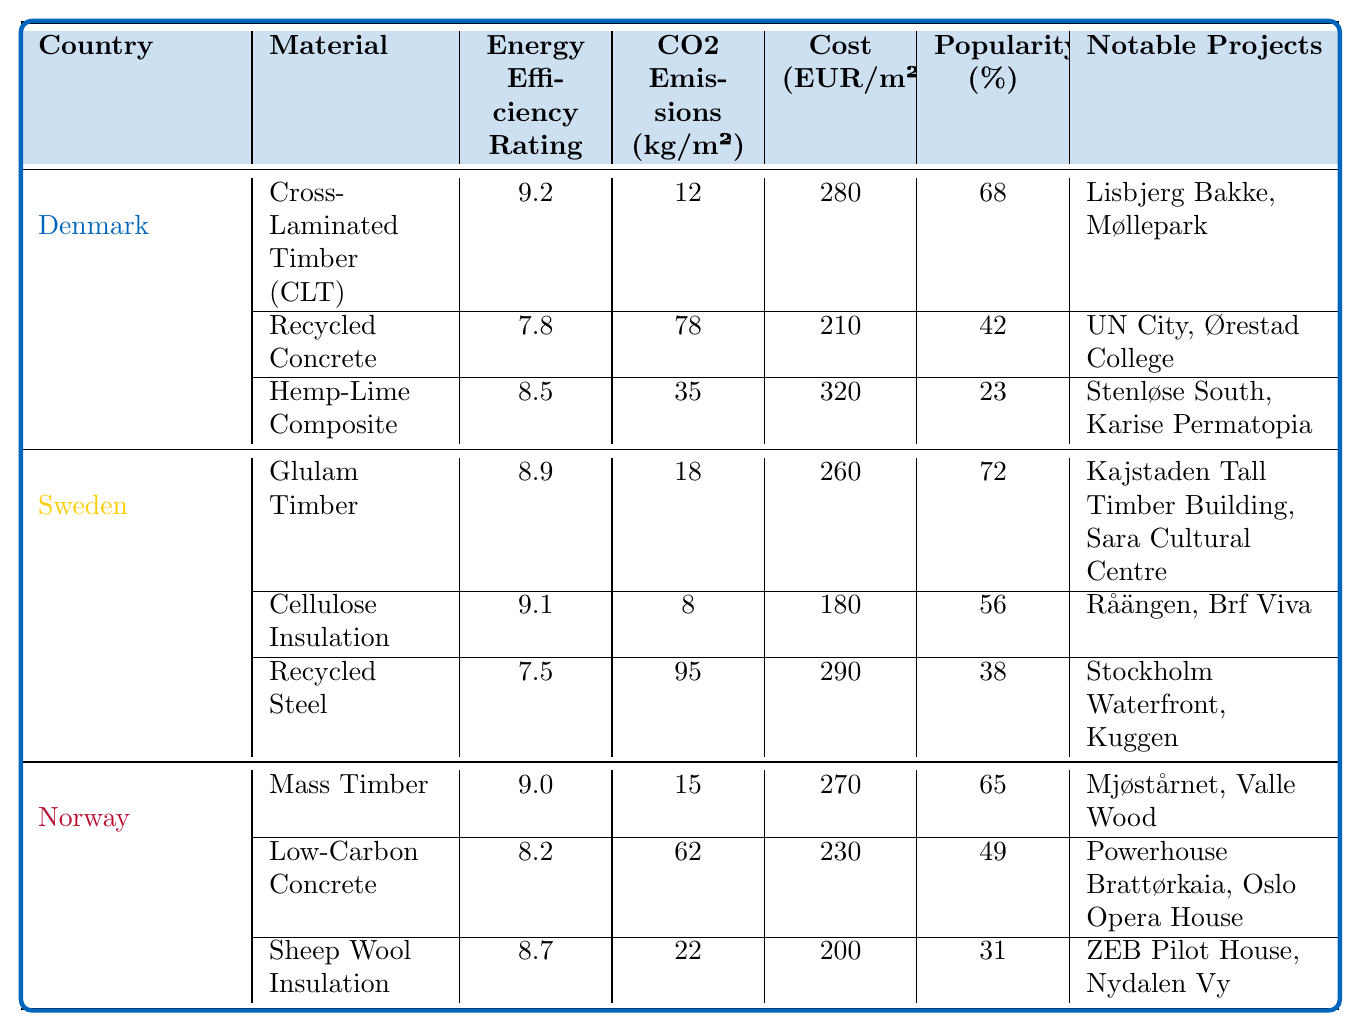What is the energy efficiency rating of Cross-Laminated Timber (CLT) in Denmark? The energy efficiency rating for Cross-Laminated Timber (CLT) is listed in the table under Denmark, where it shows a rating of 9.2.
Answer: 9.2 Which building material in Sweden has the lowest CO2 emissions per square meter? In the table for Sweden, Cellulose Insulation has the lowest CO2 emissions at 8 kg/m² compared to Glulam Timber (18 kg/m²) and Recycled Steel (95 kg/m²).
Answer: Cellulose Insulation What is the cost per square meter of Hemp-Lime Composite in Denmark? The table indicates that the cost of Hemp-Lime Composite in Denmark is 320 EUR/m².
Answer: 320 What are the notable projects that utilize Low-Carbon Concrete in Norway? Referring to the table, the notable projects using Low-Carbon Concrete in Norway are Powerhouse Brattørkaia and Oslo Opera House.
Answer: Powerhouse Brattørkaia, Oslo Opera House Which country has the building material with the highest energy efficiency rating? Denmark has Cross-Laminated Timber (CLT) with the highest energy efficiency rating of 9.2, which is greater than Sweden's highest rating of 9.1 (Cellulose Insulation) and Norway's highest rating of 9.0 (Mass Timber).
Answer: Denmark If we consider the average popularity of building materials in Norway, what is it? The popularity percentages for Norway's building materials are 65% (Mass Timber), 49% (Low-Carbon Concrete), and 31% (Sheep Wool Insulation). The average is calculated as (65 + 49 + 31) / 3 = 48.33%.
Answer: 48.33 Is the energy efficiency rating of Recycled Concrete higher than 8.0? The table lists the energy efficiency rating of Recycled Concrete as 7.8, which is lower than 8.0, so the answer is no.
Answer: No Which building material in Sweden is the most popular? By checking the popularity percentages in the table for Sweden, Glulam Timber has the highest popularity at 72%, compared to 56% for Cellulose Insulation and 38% for Recycled Steel.
Answer: Glulam Timber What is the difference in cost between the most expensive material in Denmark and the least expensive material in Sweden? In Denmark, the most expensive material is Hemp-Lime Composite at 320 EUR/m². In Sweden, the least expensive material is Cellulose Insulation at 180 EUR/m². The difference is 320 - 180 = 140 EUR/m².
Answer: 140 What is the total CO2 emissions from the three building materials in Norway? The CO2 emissions for Norway's materials are 15 kg/m² (Mass Timber), 62 kg/m² (Low-Carbon Concrete), and 22 kg/m² (Sheep Wool Insulation). The total emissions are calculated as 15 + 62 + 22 = 99 kg/m².
Answer: 99 